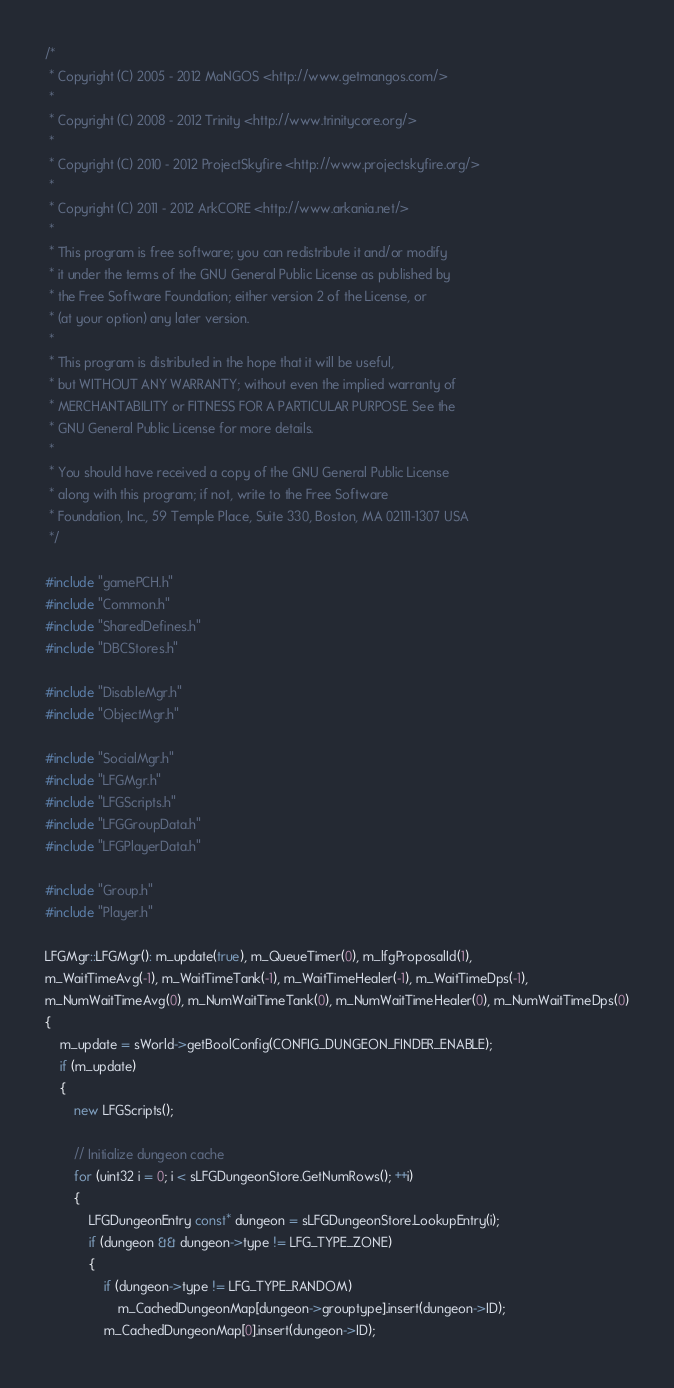<code> <loc_0><loc_0><loc_500><loc_500><_C++_>/*
 * Copyright (C) 2005 - 2012 MaNGOS <http://www.getmangos.com/>
 *
 * Copyright (C) 2008 - 2012 Trinity <http://www.trinitycore.org/>
 *
 * Copyright (C) 2010 - 2012 ProjectSkyfire <http://www.projectskyfire.org/>
 * 
 * Copyright (C) 2011 - 2012 ArkCORE <http://www.arkania.net/>
 *
 * This program is free software; you can redistribute it and/or modify
 * it under the terms of the GNU General Public License as published by
 * the Free Software Foundation; either version 2 of the License, or
 * (at your option) any later version.
 *
 * This program is distributed in the hope that it will be useful,
 * but WITHOUT ANY WARRANTY; without even the implied warranty of
 * MERCHANTABILITY or FITNESS FOR A PARTICULAR PURPOSE. See the
 * GNU General Public License for more details.
 *
 * You should have received a copy of the GNU General Public License
 * along with this program; if not, write to the Free Software
 * Foundation, Inc., 59 Temple Place, Suite 330, Boston, MA 02111-1307 USA
 */

#include "gamePCH.h"
#include "Common.h"
#include "SharedDefines.h"
#include "DBCStores.h"

#include "DisableMgr.h"
#include "ObjectMgr.h"

#include "SocialMgr.h"
#include "LFGMgr.h"
#include "LFGScripts.h"
#include "LFGGroupData.h"
#include "LFGPlayerData.h"

#include "Group.h"
#include "Player.h"

LFGMgr::LFGMgr(): m_update(true), m_QueueTimer(0), m_lfgProposalId(1),
m_WaitTimeAvg(-1), m_WaitTimeTank(-1), m_WaitTimeHealer(-1), m_WaitTimeDps(-1),
m_NumWaitTimeAvg(0), m_NumWaitTimeTank(0), m_NumWaitTimeHealer(0), m_NumWaitTimeDps(0)
{
    m_update = sWorld->getBoolConfig(CONFIG_DUNGEON_FINDER_ENABLE);
    if (m_update)
    {
        new LFGScripts();

        // Initialize dungeon cache
        for (uint32 i = 0; i < sLFGDungeonStore.GetNumRows(); ++i)
        {
            LFGDungeonEntry const* dungeon = sLFGDungeonStore.LookupEntry(i);
            if (dungeon && dungeon->type != LFG_TYPE_ZONE)
            {
                if (dungeon->type != LFG_TYPE_RANDOM)
                    m_CachedDungeonMap[dungeon->grouptype].insert(dungeon->ID);
                m_CachedDungeonMap[0].insert(dungeon->ID);</code> 